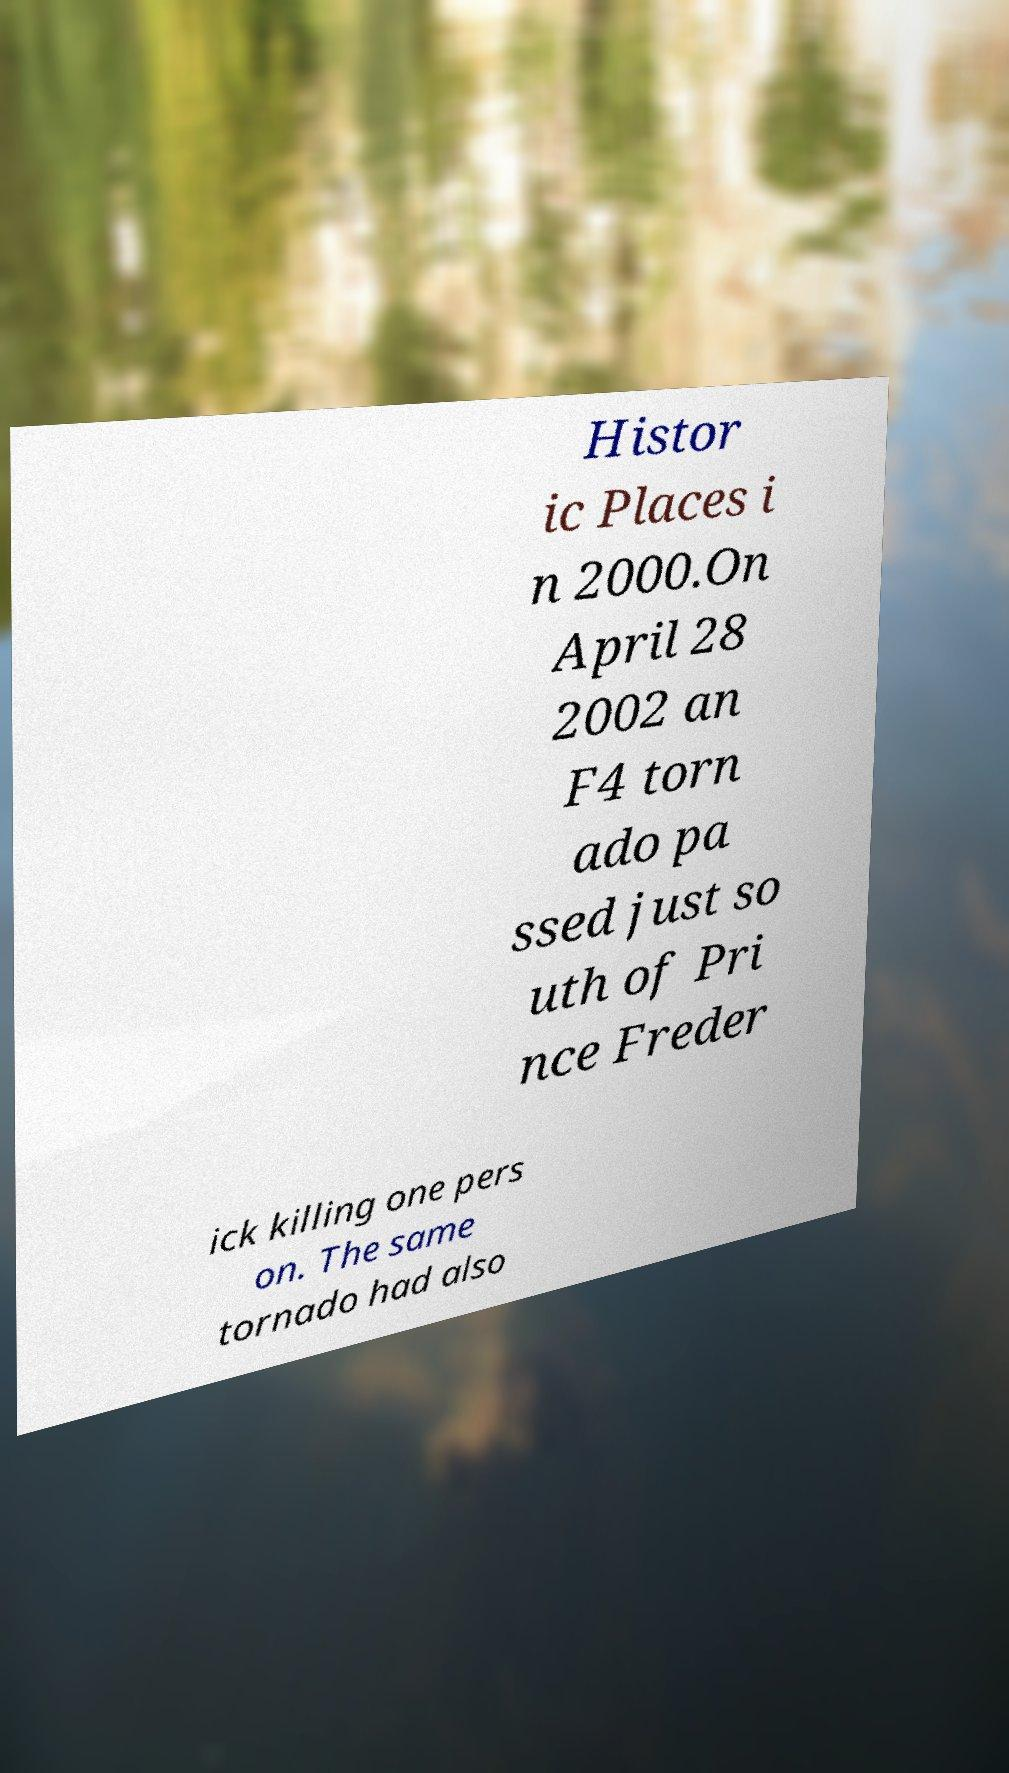I need the written content from this picture converted into text. Can you do that? Histor ic Places i n 2000.On April 28 2002 an F4 torn ado pa ssed just so uth of Pri nce Freder ick killing one pers on. The same tornado had also 